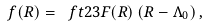Convert formula to latex. <formula><loc_0><loc_0><loc_500><loc_500>f ( R ) = \ f t 2 3 F ( R ) \, ( R - \Lambda _ { 0 } ) \, ,</formula> 